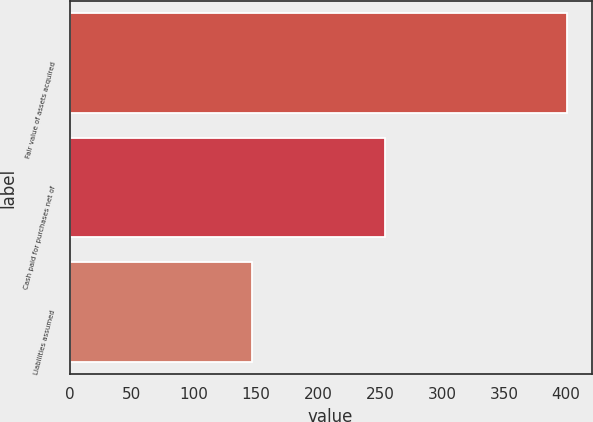Convert chart. <chart><loc_0><loc_0><loc_500><loc_500><bar_chart><fcel>Fair value of assets acquired<fcel>Cash paid for purchases net of<fcel>Liabilities assumed<nl><fcel>400.5<fcel>254<fcel>146.5<nl></chart> 